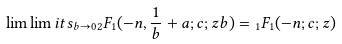Convert formula to latex. <formula><loc_0><loc_0><loc_500><loc_500>\lim \lim i t s _ { b \to 0 } { _ { 2 } } F _ { 1 } ( - n , \frac { 1 } { b } + a ; c ; z b ) = { _ { 1 } } F _ { 1 } ( - n ; c ; z )</formula> 